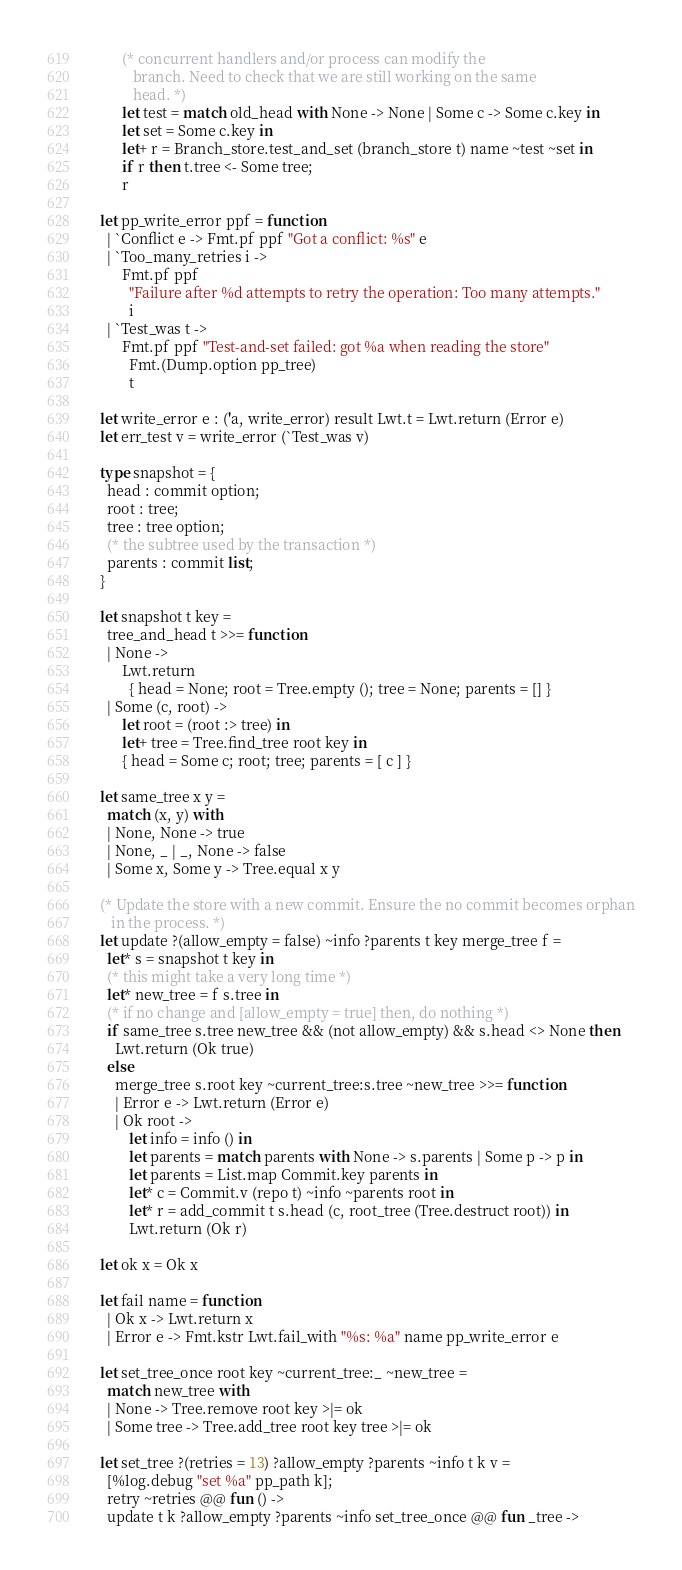<code> <loc_0><loc_0><loc_500><loc_500><_OCaml_>        (* concurrent handlers and/or process can modify the
           branch. Need to check that we are still working on the same
           head. *)
        let test = match old_head with None -> None | Some c -> Some c.key in
        let set = Some c.key in
        let+ r = Branch_store.test_and_set (branch_store t) name ~test ~set in
        if r then t.tree <- Some tree;
        r

  let pp_write_error ppf = function
    | `Conflict e -> Fmt.pf ppf "Got a conflict: %s" e
    | `Too_many_retries i ->
        Fmt.pf ppf
          "Failure after %d attempts to retry the operation: Too many attempts."
          i
    | `Test_was t ->
        Fmt.pf ppf "Test-and-set failed: got %a when reading the store"
          Fmt.(Dump.option pp_tree)
          t

  let write_error e : ('a, write_error) result Lwt.t = Lwt.return (Error e)
  let err_test v = write_error (`Test_was v)

  type snapshot = {
    head : commit option;
    root : tree;
    tree : tree option;
    (* the subtree used by the transaction *)
    parents : commit list;
  }

  let snapshot t key =
    tree_and_head t >>= function
    | None ->
        Lwt.return
          { head = None; root = Tree.empty (); tree = None; parents = [] }
    | Some (c, root) ->
        let root = (root :> tree) in
        let+ tree = Tree.find_tree root key in
        { head = Some c; root; tree; parents = [ c ] }

  let same_tree x y =
    match (x, y) with
    | None, None -> true
    | None, _ | _, None -> false
    | Some x, Some y -> Tree.equal x y

  (* Update the store with a new commit. Ensure the no commit becomes orphan
     in the process. *)
  let update ?(allow_empty = false) ~info ?parents t key merge_tree f =
    let* s = snapshot t key in
    (* this might take a very long time *)
    let* new_tree = f s.tree in
    (* if no change and [allow_empty = true] then, do nothing *)
    if same_tree s.tree new_tree && (not allow_empty) && s.head <> None then
      Lwt.return (Ok true)
    else
      merge_tree s.root key ~current_tree:s.tree ~new_tree >>= function
      | Error e -> Lwt.return (Error e)
      | Ok root ->
          let info = info () in
          let parents = match parents with None -> s.parents | Some p -> p in
          let parents = List.map Commit.key parents in
          let* c = Commit.v (repo t) ~info ~parents root in
          let* r = add_commit t s.head (c, root_tree (Tree.destruct root)) in
          Lwt.return (Ok r)

  let ok x = Ok x

  let fail name = function
    | Ok x -> Lwt.return x
    | Error e -> Fmt.kstr Lwt.fail_with "%s: %a" name pp_write_error e

  let set_tree_once root key ~current_tree:_ ~new_tree =
    match new_tree with
    | None -> Tree.remove root key >|= ok
    | Some tree -> Tree.add_tree root key tree >|= ok

  let set_tree ?(retries = 13) ?allow_empty ?parents ~info t k v =
    [%log.debug "set %a" pp_path k];
    retry ~retries @@ fun () ->
    update t k ?allow_empty ?parents ~info set_tree_once @@ fun _tree -></code> 